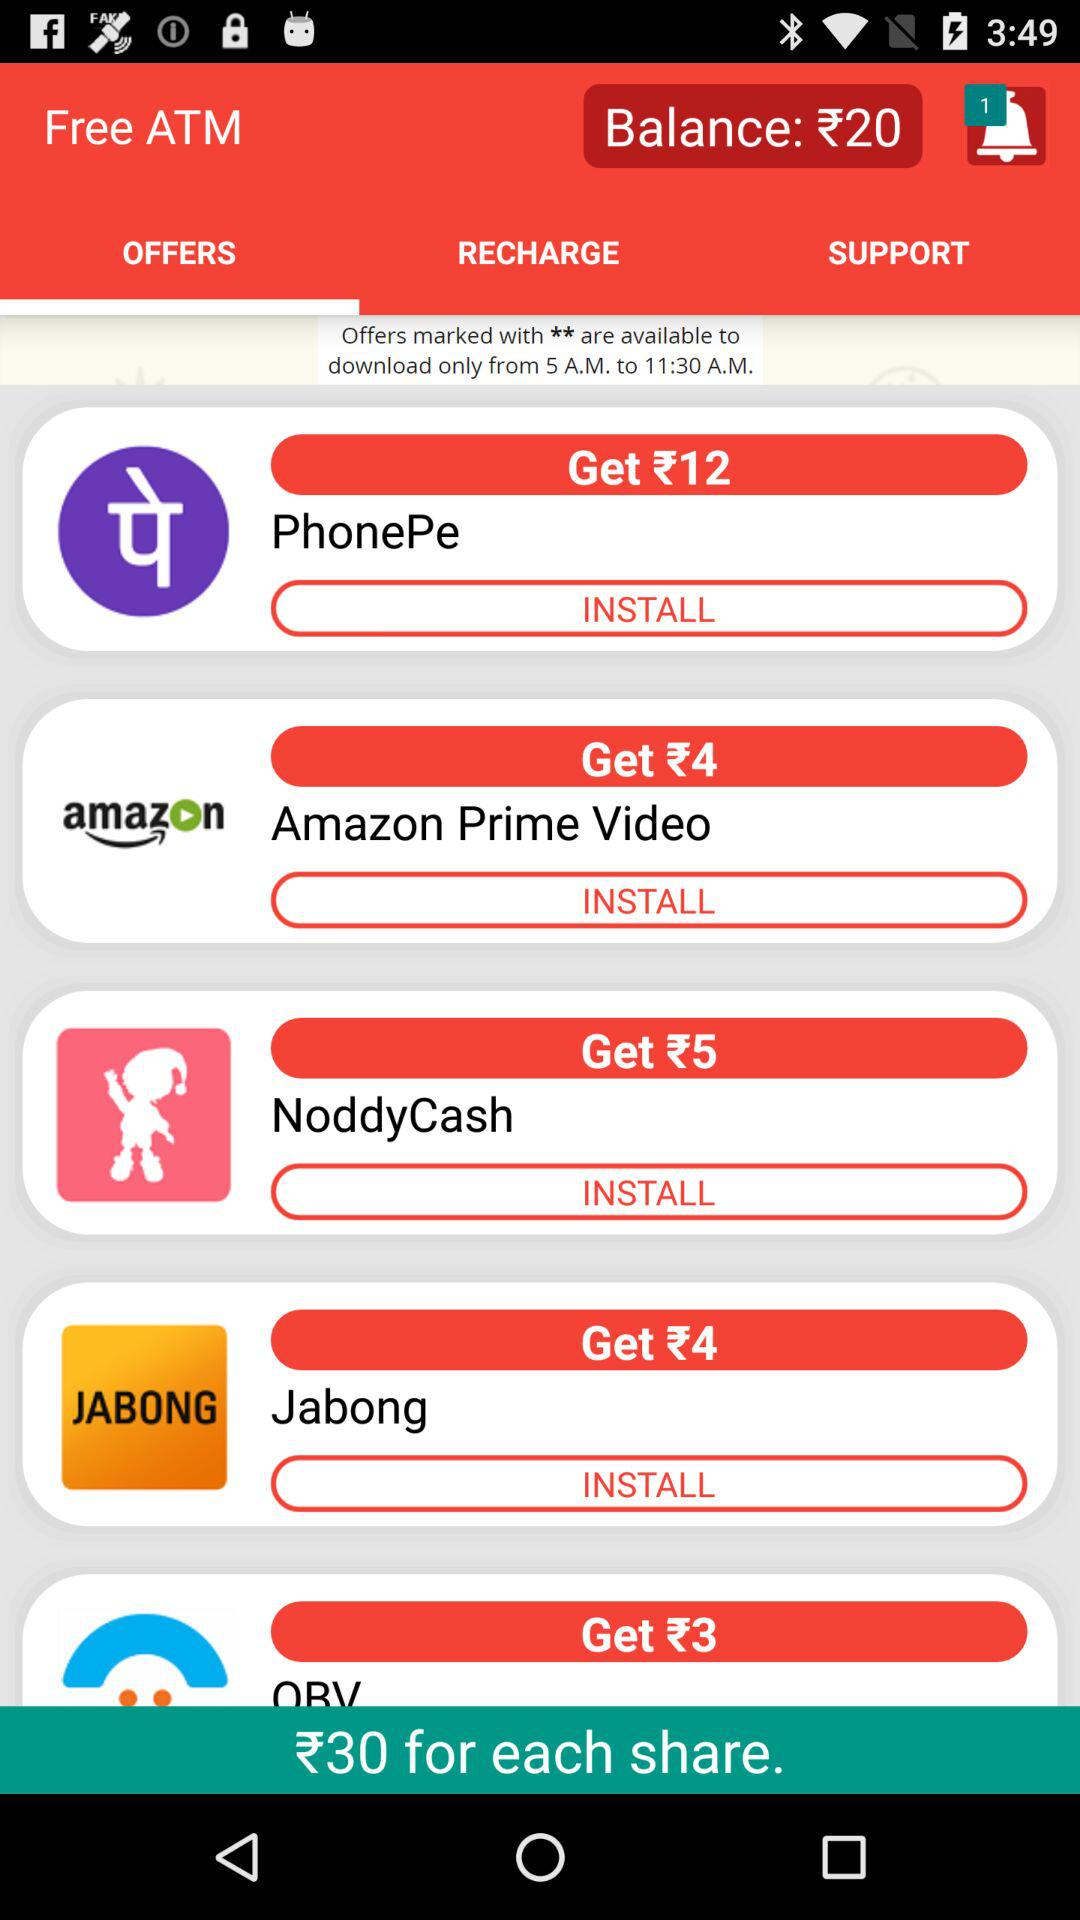How much amount will I get for installing "PhonePe"? You will get ₹12 for installing "PhonePe". 